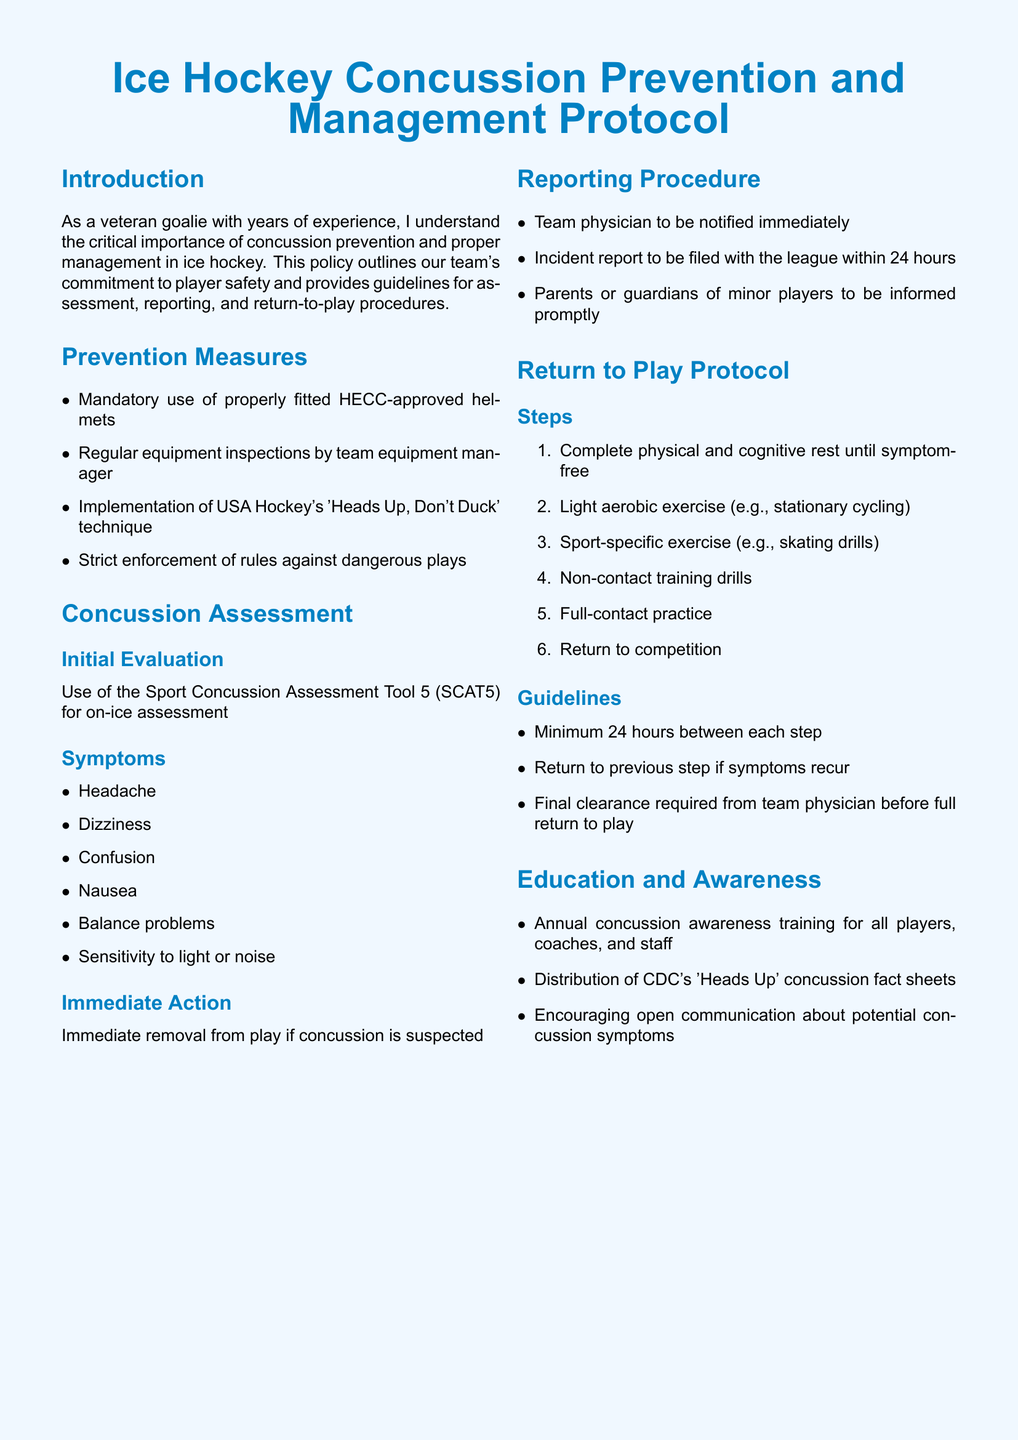What is the title of the policy document? The title is prominently displayed at the top of the document and states the subject matter clearly.
Answer: Ice Hockey Concussion Prevention and Management Protocol What tool is used for initial concussion assessment? The specific tool mandated for assessment is mentioned in the section detailing concussion evaluation procedures.
Answer: Sport Concussion Assessment Tool 5 (SCAT5) What are two symptoms of a concussion listed in the document? The symptoms are provided in a bullet list for easy identification under the concussion assessment section.
Answer: Headache, Dizziness Who should be notified immediately if a concussion is suspected? This information is found in the reporting procedure section, which outlines immediate actions to take after a concussion is suspected.
Answer: Team physician How long should there be between each step in the return-to-play protocol? This detail is specified under the guidelines section of the return to play protocol.
Answer: Minimum 24 hours What type of training is required annually for players and staff? The education section emphasizes the importance of awareness training for all involved with the team.
Answer: Concussion awareness training What must occur before a player returns to full competition? This requirement is highlighted in the return to play section, which sets the expectations for successful recovery.
Answer: Final clearance from team physician What technique is suggested to help prevent concussions? The prevention measures section states an important technique that players should implement to avoid dangerous situations leading to concussions.
Answer: Heads Up, Don't Duck What is the immediate action if a concussion is suspected? This critical step is outlined to ensure player safety during games and practices.
Answer: Immediate removal from play 